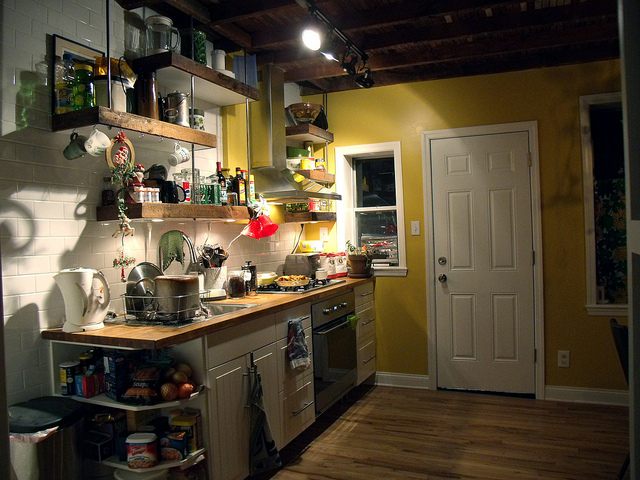<image>How many people live here? It is unknown how many people live here. What is the red pump for? It is unknown what the red pump is for. It might be for light or water. How many people live here? It is unclear how many people live here. It could be 2, 4, 3, or 1. What is the red pump for? It is ambiguous what the red pump is for. It can be used for light, water or liquids. 